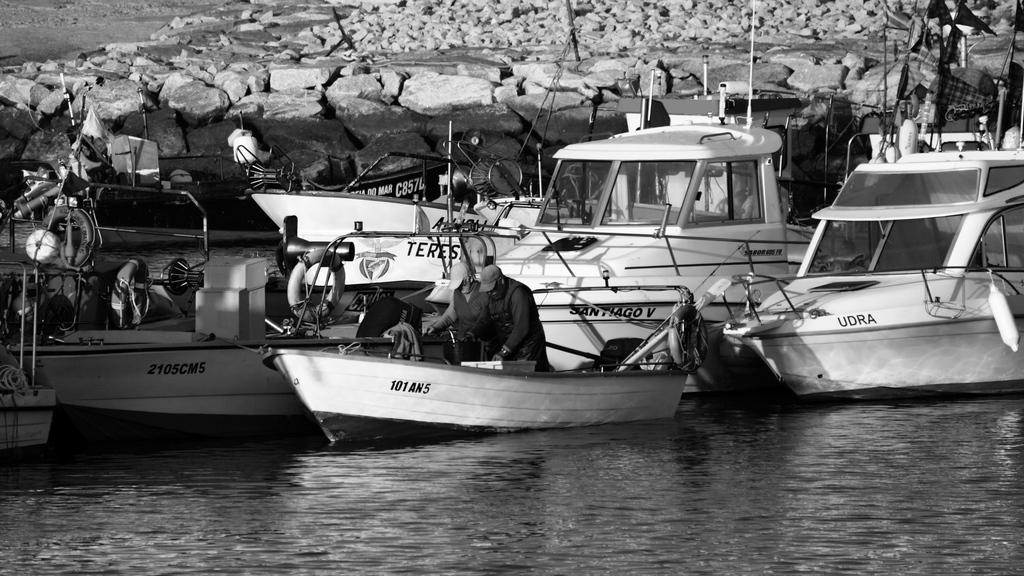Provide a one-sentence caption for the provided image. Two men are in a small fishing boat by other larger boats and one of them is named Udra. 